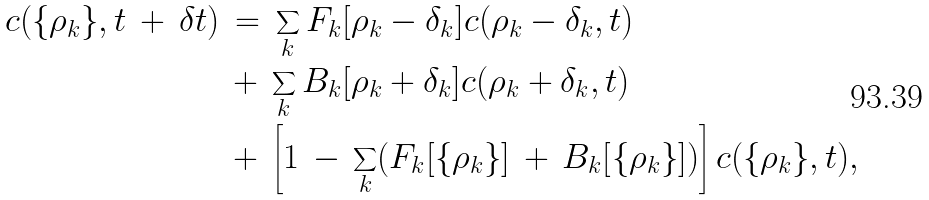<formula> <loc_0><loc_0><loc_500><loc_500>c ( \{ \rho _ { k } \} , t \, + \, \delta t ) & \, = \, \sum _ { k } F _ { k } [ \rho _ { k } - \delta _ { k } ] c ( \rho _ { k } - \delta _ { k } , t ) \\ & \, + \, \sum _ { k } B _ { k } [ \rho _ { k } + \delta _ { k } ] c ( \rho _ { k } + \delta _ { k } , t ) \\ & \, + \, \left [ 1 \, - \, \sum _ { k } ( F _ { k } [ \{ \rho _ { k } \} ] \, + \, B _ { k } [ \{ \rho _ { k } \} ] ) \right ] c ( \{ \rho _ { k } \} , t ) ,</formula> 